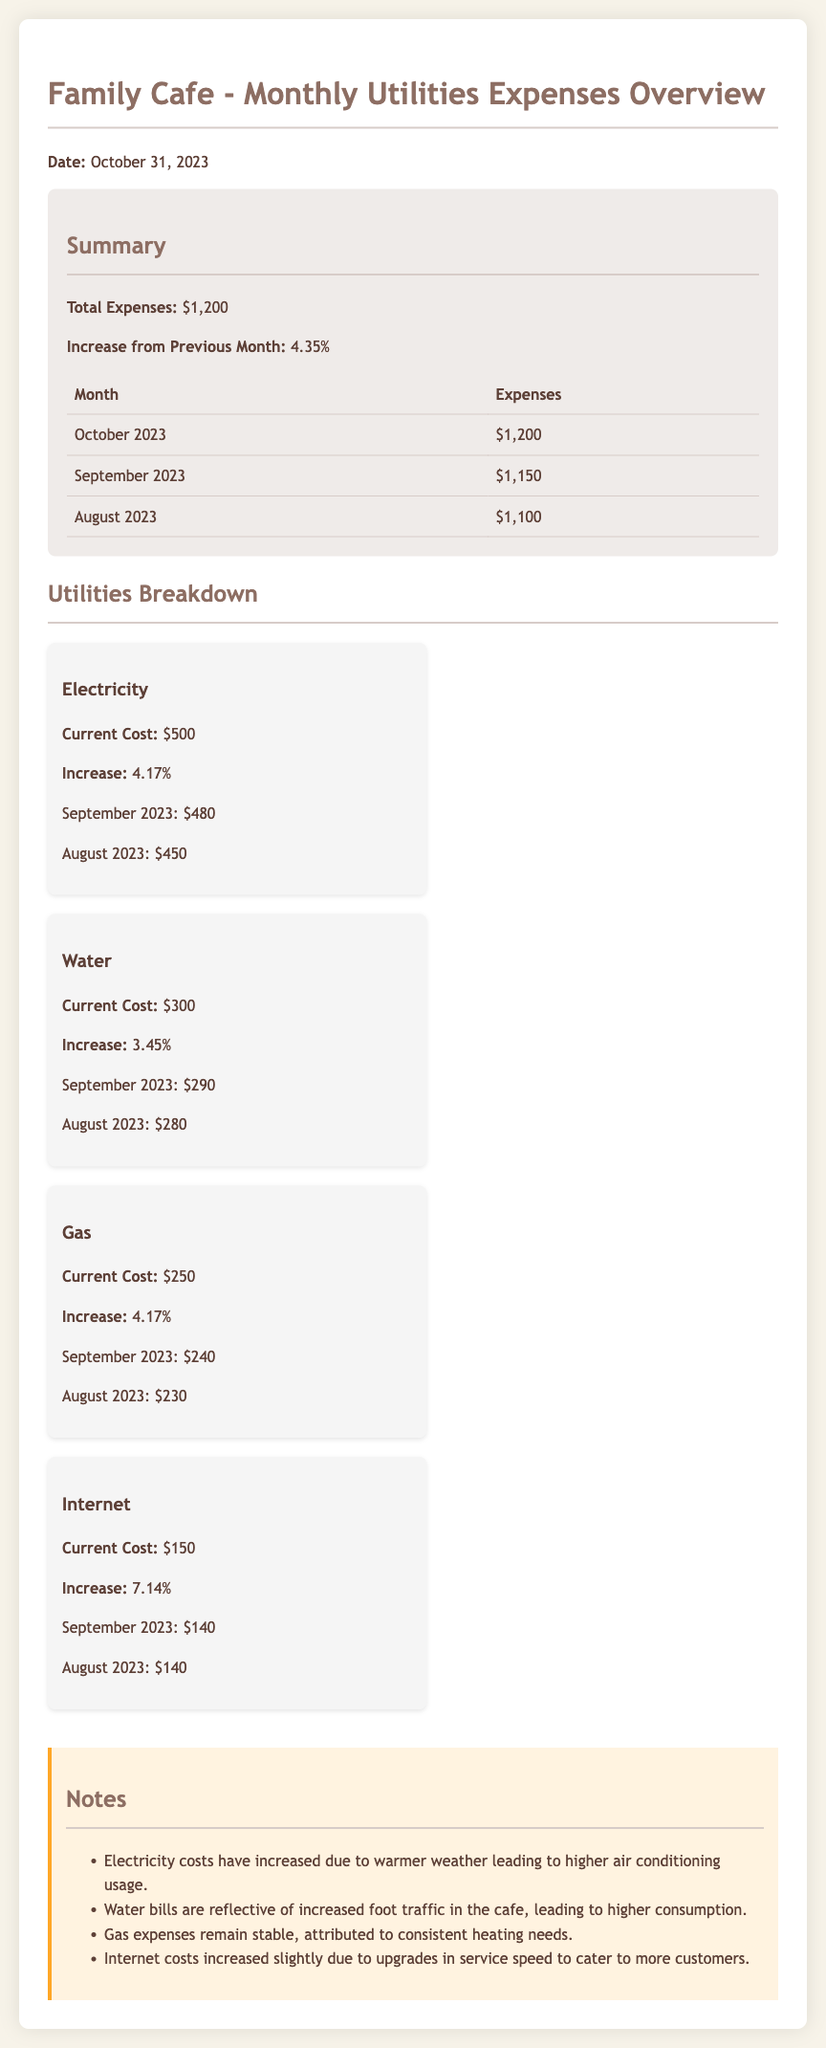What is the total expenses for October 2023? The total expenses are clearly stated in the summary section of the document, which lists the total as $1,200.
Answer: $1,200 What was the increase in expenses from September to October 2023? The increase from the previous month is displayed as 4.35% in the summary section.
Answer: 4.35% How much was spent on electricity in October 2023? The current cost for electricity is provided in the utilities breakdown section, which shows it as $500.
Answer: $500 What is the cost of internet in October 2023? The current internet cost is specified in the utilities breakdown section, listed as $150.
Answer: $150 Which utility expenses increased the most percentage-wise in October 2023? The utility with the highest percentage increase is internet, with an increase of 7.14% mentioned in the breakdown.
Answer: Internet What was the water expense in September 2023? The document lists September 2023 water expense as $290 in the utilities breakdown section.
Answer: $290 How did the gas expenses change from August to October 2023? The gas expenses in October 2023 are $250, while in August they were $230, indicating an increase, which can be inferred from the provided costs.
Answer: Increased What is the main reason for the increase in electricity costs? The document mentions that the electricity costs increased due to higher air conditioning usage because of warmer weather.
Answer: Warmer weather What is included in the notes section? The notes section includes explanations for the changes in utility costs, such as increased foot traffic and service upgrades.
Answer: Explanations for cost changes 